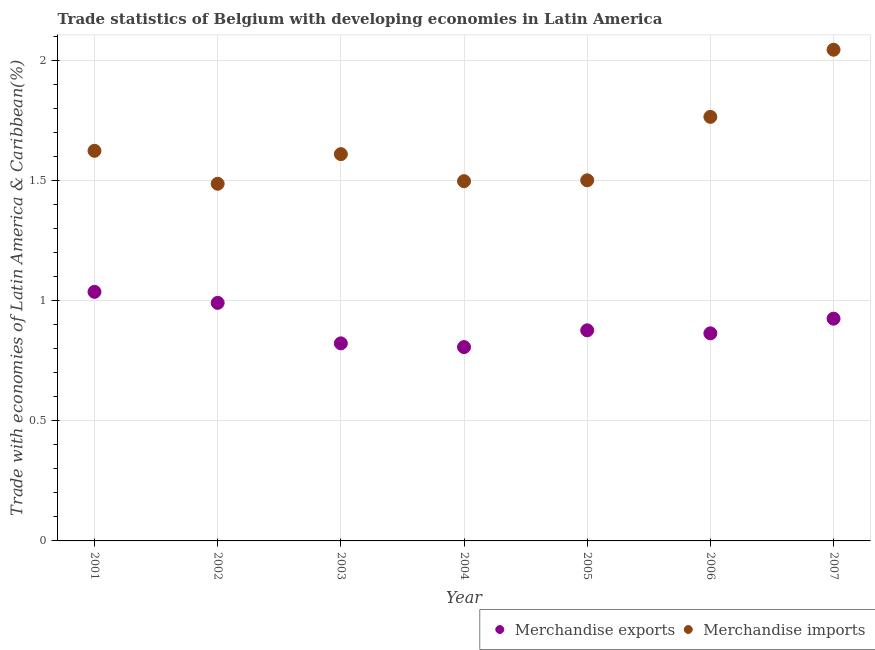Is the number of dotlines equal to the number of legend labels?
Your answer should be compact. Yes. What is the merchandise imports in 2006?
Your answer should be compact. 1.77. Across all years, what is the maximum merchandise exports?
Offer a terse response. 1.04. Across all years, what is the minimum merchandise imports?
Your response must be concise. 1.49. In which year was the merchandise imports maximum?
Keep it short and to the point. 2007. In which year was the merchandise exports minimum?
Offer a terse response. 2004. What is the total merchandise imports in the graph?
Provide a succinct answer. 11.54. What is the difference between the merchandise imports in 2003 and that in 2005?
Ensure brevity in your answer.  0.11. What is the difference between the merchandise exports in 2001 and the merchandise imports in 2004?
Keep it short and to the point. -0.46. What is the average merchandise exports per year?
Give a very brief answer. 0.9. In the year 2006, what is the difference between the merchandise exports and merchandise imports?
Give a very brief answer. -0.9. In how many years, is the merchandise imports greater than 0.30000000000000004 %?
Make the answer very short. 7. What is the ratio of the merchandise exports in 2001 to that in 2006?
Offer a very short reply. 1.2. Is the merchandise exports in 2002 less than that in 2004?
Give a very brief answer. No. Is the difference between the merchandise exports in 2001 and 2007 greater than the difference between the merchandise imports in 2001 and 2007?
Provide a succinct answer. Yes. What is the difference between the highest and the second highest merchandise exports?
Your answer should be very brief. 0.05. What is the difference between the highest and the lowest merchandise exports?
Provide a short and direct response. 0.23. In how many years, is the merchandise exports greater than the average merchandise exports taken over all years?
Ensure brevity in your answer.  3. Is the merchandise exports strictly greater than the merchandise imports over the years?
Make the answer very short. No. Is the merchandise exports strictly less than the merchandise imports over the years?
Offer a terse response. Yes. How many dotlines are there?
Provide a short and direct response. 2. What is the difference between two consecutive major ticks on the Y-axis?
Make the answer very short. 0.5. How are the legend labels stacked?
Ensure brevity in your answer.  Horizontal. What is the title of the graph?
Keep it short and to the point. Trade statistics of Belgium with developing economies in Latin America. Does "Methane emissions" appear as one of the legend labels in the graph?
Your response must be concise. No. What is the label or title of the Y-axis?
Give a very brief answer. Trade with economies of Latin America & Caribbean(%). What is the Trade with economies of Latin America & Caribbean(%) of Merchandise exports in 2001?
Your answer should be compact. 1.04. What is the Trade with economies of Latin America & Caribbean(%) of Merchandise imports in 2001?
Offer a very short reply. 1.63. What is the Trade with economies of Latin America & Caribbean(%) in Merchandise exports in 2002?
Offer a very short reply. 0.99. What is the Trade with economies of Latin America & Caribbean(%) in Merchandise imports in 2002?
Provide a short and direct response. 1.49. What is the Trade with economies of Latin America & Caribbean(%) of Merchandise exports in 2003?
Make the answer very short. 0.82. What is the Trade with economies of Latin America & Caribbean(%) of Merchandise imports in 2003?
Give a very brief answer. 1.61. What is the Trade with economies of Latin America & Caribbean(%) of Merchandise exports in 2004?
Give a very brief answer. 0.81. What is the Trade with economies of Latin America & Caribbean(%) in Merchandise imports in 2004?
Provide a succinct answer. 1.5. What is the Trade with economies of Latin America & Caribbean(%) in Merchandise exports in 2005?
Your response must be concise. 0.88. What is the Trade with economies of Latin America & Caribbean(%) of Merchandise imports in 2005?
Provide a succinct answer. 1.5. What is the Trade with economies of Latin America & Caribbean(%) of Merchandise exports in 2006?
Provide a short and direct response. 0.86. What is the Trade with economies of Latin America & Caribbean(%) of Merchandise imports in 2006?
Ensure brevity in your answer.  1.77. What is the Trade with economies of Latin America & Caribbean(%) of Merchandise exports in 2007?
Your response must be concise. 0.93. What is the Trade with economies of Latin America & Caribbean(%) in Merchandise imports in 2007?
Your answer should be very brief. 2.05. Across all years, what is the maximum Trade with economies of Latin America & Caribbean(%) in Merchandise exports?
Give a very brief answer. 1.04. Across all years, what is the maximum Trade with economies of Latin America & Caribbean(%) in Merchandise imports?
Offer a very short reply. 2.05. Across all years, what is the minimum Trade with economies of Latin America & Caribbean(%) of Merchandise exports?
Make the answer very short. 0.81. Across all years, what is the minimum Trade with economies of Latin America & Caribbean(%) of Merchandise imports?
Your response must be concise. 1.49. What is the total Trade with economies of Latin America & Caribbean(%) in Merchandise exports in the graph?
Offer a very short reply. 6.33. What is the total Trade with economies of Latin America & Caribbean(%) in Merchandise imports in the graph?
Offer a very short reply. 11.54. What is the difference between the Trade with economies of Latin America & Caribbean(%) of Merchandise exports in 2001 and that in 2002?
Provide a succinct answer. 0.05. What is the difference between the Trade with economies of Latin America & Caribbean(%) of Merchandise imports in 2001 and that in 2002?
Provide a succinct answer. 0.14. What is the difference between the Trade with economies of Latin America & Caribbean(%) of Merchandise exports in 2001 and that in 2003?
Offer a terse response. 0.21. What is the difference between the Trade with economies of Latin America & Caribbean(%) in Merchandise imports in 2001 and that in 2003?
Offer a terse response. 0.01. What is the difference between the Trade with economies of Latin America & Caribbean(%) in Merchandise exports in 2001 and that in 2004?
Offer a terse response. 0.23. What is the difference between the Trade with economies of Latin America & Caribbean(%) of Merchandise imports in 2001 and that in 2004?
Make the answer very short. 0.13. What is the difference between the Trade with economies of Latin America & Caribbean(%) of Merchandise exports in 2001 and that in 2005?
Provide a succinct answer. 0.16. What is the difference between the Trade with economies of Latin America & Caribbean(%) in Merchandise imports in 2001 and that in 2005?
Offer a very short reply. 0.12. What is the difference between the Trade with economies of Latin America & Caribbean(%) in Merchandise exports in 2001 and that in 2006?
Make the answer very short. 0.17. What is the difference between the Trade with economies of Latin America & Caribbean(%) in Merchandise imports in 2001 and that in 2006?
Give a very brief answer. -0.14. What is the difference between the Trade with economies of Latin America & Caribbean(%) in Merchandise exports in 2001 and that in 2007?
Offer a terse response. 0.11. What is the difference between the Trade with economies of Latin America & Caribbean(%) in Merchandise imports in 2001 and that in 2007?
Provide a succinct answer. -0.42. What is the difference between the Trade with economies of Latin America & Caribbean(%) of Merchandise exports in 2002 and that in 2003?
Your answer should be very brief. 0.17. What is the difference between the Trade with economies of Latin America & Caribbean(%) of Merchandise imports in 2002 and that in 2003?
Ensure brevity in your answer.  -0.12. What is the difference between the Trade with economies of Latin America & Caribbean(%) of Merchandise exports in 2002 and that in 2004?
Your answer should be very brief. 0.18. What is the difference between the Trade with economies of Latin America & Caribbean(%) of Merchandise imports in 2002 and that in 2004?
Keep it short and to the point. -0.01. What is the difference between the Trade with economies of Latin America & Caribbean(%) in Merchandise exports in 2002 and that in 2005?
Offer a terse response. 0.11. What is the difference between the Trade with economies of Latin America & Caribbean(%) in Merchandise imports in 2002 and that in 2005?
Your answer should be very brief. -0.01. What is the difference between the Trade with economies of Latin America & Caribbean(%) of Merchandise exports in 2002 and that in 2006?
Provide a succinct answer. 0.13. What is the difference between the Trade with economies of Latin America & Caribbean(%) in Merchandise imports in 2002 and that in 2006?
Offer a terse response. -0.28. What is the difference between the Trade with economies of Latin America & Caribbean(%) in Merchandise exports in 2002 and that in 2007?
Ensure brevity in your answer.  0.07. What is the difference between the Trade with economies of Latin America & Caribbean(%) in Merchandise imports in 2002 and that in 2007?
Keep it short and to the point. -0.56. What is the difference between the Trade with economies of Latin America & Caribbean(%) in Merchandise exports in 2003 and that in 2004?
Keep it short and to the point. 0.02. What is the difference between the Trade with economies of Latin America & Caribbean(%) of Merchandise imports in 2003 and that in 2004?
Offer a terse response. 0.11. What is the difference between the Trade with economies of Latin America & Caribbean(%) in Merchandise exports in 2003 and that in 2005?
Make the answer very short. -0.05. What is the difference between the Trade with economies of Latin America & Caribbean(%) of Merchandise imports in 2003 and that in 2005?
Give a very brief answer. 0.11. What is the difference between the Trade with economies of Latin America & Caribbean(%) in Merchandise exports in 2003 and that in 2006?
Make the answer very short. -0.04. What is the difference between the Trade with economies of Latin America & Caribbean(%) of Merchandise imports in 2003 and that in 2006?
Make the answer very short. -0.16. What is the difference between the Trade with economies of Latin America & Caribbean(%) of Merchandise exports in 2003 and that in 2007?
Your response must be concise. -0.1. What is the difference between the Trade with economies of Latin America & Caribbean(%) of Merchandise imports in 2003 and that in 2007?
Your answer should be very brief. -0.43. What is the difference between the Trade with economies of Latin America & Caribbean(%) in Merchandise exports in 2004 and that in 2005?
Ensure brevity in your answer.  -0.07. What is the difference between the Trade with economies of Latin America & Caribbean(%) in Merchandise imports in 2004 and that in 2005?
Provide a short and direct response. -0. What is the difference between the Trade with economies of Latin America & Caribbean(%) of Merchandise exports in 2004 and that in 2006?
Offer a very short reply. -0.06. What is the difference between the Trade with economies of Latin America & Caribbean(%) in Merchandise imports in 2004 and that in 2006?
Keep it short and to the point. -0.27. What is the difference between the Trade with economies of Latin America & Caribbean(%) of Merchandise exports in 2004 and that in 2007?
Provide a short and direct response. -0.12. What is the difference between the Trade with economies of Latin America & Caribbean(%) of Merchandise imports in 2004 and that in 2007?
Your answer should be compact. -0.55. What is the difference between the Trade with economies of Latin America & Caribbean(%) of Merchandise exports in 2005 and that in 2006?
Keep it short and to the point. 0.01. What is the difference between the Trade with economies of Latin America & Caribbean(%) of Merchandise imports in 2005 and that in 2006?
Provide a succinct answer. -0.26. What is the difference between the Trade with economies of Latin America & Caribbean(%) in Merchandise exports in 2005 and that in 2007?
Ensure brevity in your answer.  -0.05. What is the difference between the Trade with economies of Latin America & Caribbean(%) in Merchandise imports in 2005 and that in 2007?
Ensure brevity in your answer.  -0.54. What is the difference between the Trade with economies of Latin America & Caribbean(%) in Merchandise exports in 2006 and that in 2007?
Keep it short and to the point. -0.06. What is the difference between the Trade with economies of Latin America & Caribbean(%) in Merchandise imports in 2006 and that in 2007?
Make the answer very short. -0.28. What is the difference between the Trade with economies of Latin America & Caribbean(%) in Merchandise exports in 2001 and the Trade with economies of Latin America & Caribbean(%) in Merchandise imports in 2002?
Offer a very short reply. -0.45. What is the difference between the Trade with economies of Latin America & Caribbean(%) in Merchandise exports in 2001 and the Trade with economies of Latin America & Caribbean(%) in Merchandise imports in 2003?
Give a very brief answer. -0.57. What is the difference between the Trade with economies of Latin America & Caribbean(%) in Merchandise exports in 2001 and the Trade with economies of Latin America & Caribbean(%) in Merchandise imports in 2004?
Make the answer very short. -0.46. What is the difference between the Trade with economies of Latin America & Caribbean(%) in Merchandise exports in 2001 and the Trade with economies of Latin America & Caribbean(%) in Merchandise imports in 2005?
Your answer should be very brief. -0.46. What is the difference between the Trade with economies of Latin America & Caribbean(%) of Merchandise exports in 2001 and the Trade with economies of Latin America & Caribbean(%) of Merchandise imports in 2006?
Provide a succinct answer. -0.73. What is the difference between the Trade with economies of Latin America & Caribbean(%) of Merchandise exports in 2001 and the Trade with economies of Latin America & Caribbean(%) of Merchandise imports in 2007?
Offer a very short reply. -1.01. What is the difference between the Trade with economies of Latin America & Caribbean(%) of Merchandise exports in 2002 and the Trade with economies of Latin America & Caribbean(%) of Merchandise imports in 2003?
Keep it short and to the point. -0.62. What is the difference between the Trade with economies of Latin America & Caribbean(%) in Merchandise exports in 2002 and the Trade with economies of Latin America & Caribbean(%) in Merchandise imports in 2004?
Provide a short and direct response. -0.51. What is the difference between the Trade with economies of Latin America & Caribbean(%) in Merchandise exports in 2002 and the Trade with economies of Latin America & Caribbean(%) in Merchandise imports in 2005?
Keep it short and to the point. -0.51. What is the difference between the Trade with economies of Latin America & Caribbean(%) of Merchandise exports in 2002 and the Trade with economies of Latin America & Caribbean(%) of Merchandise imports in 2006?
Give a very brief answer. -0.77. What is the difference between the Trade with economies of Latin America & Caribbean(%) in Merchandise exports in 2002 and the Trade with economies of Latin America & Caribbean(%) in Merchandise imports in 2007?
Ensure brevity in your answer.  -1.05. What is the difference between the Trade with economies of Latin America & Caribbean(%) of Merchandise exports in 2003 and the Trade with economies of Latin America & Caribbean(%) of Merchandise imports in 2004?
Your answer should be very brief. -0.68. What is the difference between the Trade with economies of Latin America & Caribbean(%) in Merchandise exports in 2003 and the Trade with economies of Latin America & Caribbean(%) in Merchandise imports in 2005?
Keep it short and to the point. -0.68. What is the difference between the Trade with economies of Latin America & Caribbean(%) of Merchandise exports in 2003 and the Trade with economies of Latin America & Caribbean(%) of Merchandise imports in 2006?
Make the answer very short. -0.94. What is the difference between the Trade with economies of Latin America & Caribbean(%) of Merchandise exports in 2003 and the Trade with economies of Latin America & Caribbean(%) of Merchandise imports in 2007?
Give a very brief answer. -1.22. What is the difference between the Trade with economies of Latin America & Caribbean(%) in Merchandise exports in 2004 and the Trade with economies of Latin America & Caribbean(%) in Merchandise imports in 2005?
Give a very brief answer. -0.69. What is the difference between the Trade with economies of Latin America & Caribbean(%) of Merchandise exports in 2004 and the Trade with economies of Latin America & Caribbean(%) of Merchandise imports in 2006?
Provide a succinct answer. -0.96. What is the difference between the Trade with economies of Latin America & Caribbean(%) of Merchandise exports in 2004 and the Trade with economies of Latin America & Caribbean(%) of Merchandise imports in 2007?
Keep it short and to the point. -1.24. What is the difference between the Trade with economies of Latin America & Caribbean(%) of Merchandise exports in 2005 and the Trade with economies of Latin America & Caribbean(%) of Merchandise imports in 2006?
Provide a short and direct response. -0.89. What is the difference between the Trade with economies of Latin America & Caribbean(%) of Merchandise exports in 2005 and the Trade with economies of Latin America & Caribbean(%) of Merchandise imports in 2007?
Provide a short and direct response. -1.17. What is the difference between the Trade with economies of Latin America & Caribbean(%) of Merchandise exports in 2006 and the Trade with economies of Latin America & Caribbean(%) of Merchandise imports in 2007?
Offer a very short reply. -1.18. What is the average Trade with economies of Latin America & Caribbean(%) of Merchandise exports per year?
Your answer should be compact. 0.9. What is the average Trade with economies of Latin America & Caribbean(%) in Merchandise imports per year?
Your answer should be compact. 1.65. In the year 2001, what is the difference between the Trade with economies of Latin America & Caribbean(%) of Merchandise exports and Trade with economies of Latin America & Caribbean(%) of Merchandise imports?
Offer a terse response. -0.59. In the year 2002, what is the difference between the Trade with economies of Latin America & Caribbean(%) of Merchandise exports and Trade with economies of Latin America & Caribbean(%) of Merchandise imports?
Offer a very short reply. -0.5. In the year 2003, what is the difference between the Trade with economies of Latin America & Caribbean(%) in Merchandise exports and Trade with economies of Latin America & Caribbean(%) in Merchandise imports?
Your answer should be compact. -0.79. In the year 2004, what is the difference between the Trade with economies of Latin America & Caribbean(%) in Merchandise exports and Trade with economies of Latin America & Caribbean(%) in Merchandise imports?
Offer a terse response. -0.69. In the year 2005, what is the difference between the Trade with economies of Latin America & Caribbean(%) of Merchandise exports and Trade with economies of Latin America & Caribbean(%) of Merchandise imports?
Provide a succinct answer. -0.62. In the year 2006, what is the difference between the Trade with economies of Latin America & Caribbean(%) of Merchandise exports and Trade with economies of Latin America & Caribbean(%) of Merchandise imports?
Offer a very short reply. -0.9. In the year 2007, what is the difference between the Trade with economies of Latin America & Caribbean(%) of Merchandise exports and Trade with economies of Latin America & Caribbean(%) of Merchandise imports?
Offer a terse response. -1.12. What is the ratio of the Trade with economies of Latin America & Caribbean(%) of Merchandise exports in 2001 to that in 2002?
Provide a short and direct response. 1.05. What is the ratio of the Trade with economies of Latin America & Caribbean(%) in Merchandise imports in 2001 to that in 2002?
Ensure brevity in your answer.  1.09. What is the ratio of the Trade with economies of Latin America & Caribbean(%) of Merchandise exports in 2001 to that in 2003?
Make the answer very short. 1.26. What is the ratio of the Trade with economies of Latin America & Caribbean(%) in Merchandise imports in 2001 to that in 2003?
Make the answer very short. 1.01. What is the ratio of the Trade with economies of Latin America & Caribbean(%) in Merchandise exports in 2001 to that in 2004?
Offer a very short reply. 1.28. What is the ratio of the Trade with economies of Latin America & Caribbean(%) of Merchandise imports in 2001 to that in 2004?
Your response must be concise. 1.08. What is the ratio of the Trade with economies of Latin America & Caribbean(%) of Merchandise exports in 2001 to that in 2005?
Your answer should be very brief. 1.18. What is the ratio of the Trade with economies of Latin America & Caribbean(%) in Merchandise imports in 2001 to that in 2005?
Keep it short and to the point. 1.08. What is the ratio of the Trade with economies of Latin America & Caribbean(%) of Merchandise exports in 2001 to that in 2006?
Make the answer very short. 1.2. What is the ratio of the Trade with economies of Latin America & Caribbean(%) in Merchandise imports in 2001 to that in 2006?
Your response must be concise. 0.92. What is the ratio of the Trade with economies of Latin America & Caribbean(%) in Merchandise exports in 2001 to that in 2007?
Offer a very short reply. 1.12. What is the ratio of the Trade with economies of Latin America & Caribbean(%) of Merchandise imports in 2001 to that in 2007?
Your answer should be very brief. 0.79. What is the ratio of the Trade with economies of Latin America & Caribbean(%) of Merchandise exports in 2002 to that in 2003?
Ensure brevity in your answer.  1.2. What is the ratio of the Trade with economies of Latin America & Caribbean(%) in Merchandise imports in 2002 to that in 2003?
Your response must be concise. 0.92. What is the ratio of the Trade with economies of Latin America & Caribbean(%) of Merchandise exports in 2002 to that in 2004?
Give a very brief answer. 1.23. What is the ratio of the Trade with economies of Latin America & Caribbean(%) in Merchandise exports in 2002 to that in 2005?
Your response must be concise. 1.13. What is the ratio of the Trade with economies of Latin America & Caribbean(%) in Merchandise exports in 2002 to that in 2006?
Offer a terse response. 1.15. What is the ratio of the Trade with economies of Latin America & Caribbean(%) of Merchandise imports in 2002 to that in 2006?
Make the answer very short. 0.84. What is the ratio of the Trade with economies of Latin America & Caribbean(%) of Merchandise exports in 2002 to that in 2007?
Make the answer very short. 1.07. What is the ratio of the Trade with economies of Latin America & Caribbean(%) of Merchandise imports in 2002 to that in 2007?
Your response must be concise. 0.73. What is the ratio of the Trade with economies of Latin America & Caribbean(%) of Merchandise exports in 2003 to that in 2004?
Offer a very short reply. 1.02. What is the ratio of the Trade with economies of Latin America & Caribbean(%) in Merchandise imports in 2003 to that in 2004?
Your answer should be very brief. 1.08. What is the ratio of the Trade with economies of Latin America & Caribbean(%) of Merchandise exports in 2003 to that in 2005?
Provide a short and direct response. 0.94. What is the ratio of the Trade with economies of Latin America & Caribbean(%) in Merchandise imports in 2003 to that in 2005?
Your answer should be compact. 1.07. What is the ratio of the Trade with economies of Latin America & Caribbean(%) of Merchandise exports in 2003 to that in 2006?
Give a very brief answer. 0.95. What is the ratio of the Trade with economies of Latin America & Caribbean(%) of Merchandise imports in 2003 to that in 2006?
Your answer should be very brief. 0.91. What is the ratio of the Trade with economies of Latin America & Caribbean(%) in Merchandise exports in 2003 to that in 2007?
Your response must be concise. 0.89. What is the ratio of the Trade with economies of Latin America & Caribbean(%) in Merchandise imports in 2003 to that in 2007?
Ensure brevity in your answer.  0.79. What is the ratio of the Trade with economies of Latin America & Caribbean(%) in Merchandise exports in 2004 to that in 2005?
Give a very brief answer. 0.92. What is the ratio of the Trade with economies of Latin America & Caribbean(%) in Merchandise exports in 2004 to that in 2006?
Make the answer very short. 0.93. What is the ratio of the Trade with economies of Latin America & Caribbean(%) in Merchandise imports in 2004 to that in 2006?
Make the answer very short. 0.85. What is the ratio of the Trade with economies of Latin America & Caribbean(%) of Merchandise exports in 2004 to that in 2007?
Your answer should be very brief. 0.87. What is the ratio of the Trade with economies of Latin America & Caribbean(%) in Merchandise imports in 2004 to that in 2007?
Provide a succinct answer. 0.73. What is the ratio of the Trade with economies of Latin America & Caribbean(%) in Merchandise exports in 2005 to that in 2006?
Your answer should be compact. 1.01. What is the ratio of the Trade with economies of Latin America & Caribbean(%) of Merchandise imports in 2005 to that in 2006?
Your answer should be compact. 0.85. What is the ratio of the Trade with economies of Latin America & Caribbean(%) in Merchandise exports in 2005 to that in 2007?
Make the answer very short. 0.95. What is the ratio of the Trade with economies of Latin America & Caribbean(%) of Merchandise imports in 2005 to that in 2007?
Provide a short and direct response. 0.73. What is the ratio of the Trade with economies of Latin America & Caribbean(%) in Merchandise exports in 2006 to that in 2007?
Provide a succinct answer. 0.93. What is the ratio of the Trade with economies of Latin America & Caribbean(%) in Merchandise imports in 2006 to that in 2007?
Offer a very short reply. 0.86. What is the difference between the highest and the second highest Trade with economies of Latin America & Caribbean(%) of Merchandise exports?
Your response must be concise. 0.05. What is the difference between the highest and the second highest Trade with economies of Latin America & Caribbean(%) in Merchandise imports?
Offer a terse response. 0.28. What is the difference between the highest and the lowest Trade with economies of Latin America & Caribbean(%) of Merchandise exports?
Ensure brevity in your answer.  0.23. What is the difference between the highest and the lowest Trade with economies of Latin America & Caribbean(%) of Merchandise imports?
Your response must be concise. 0.56. 